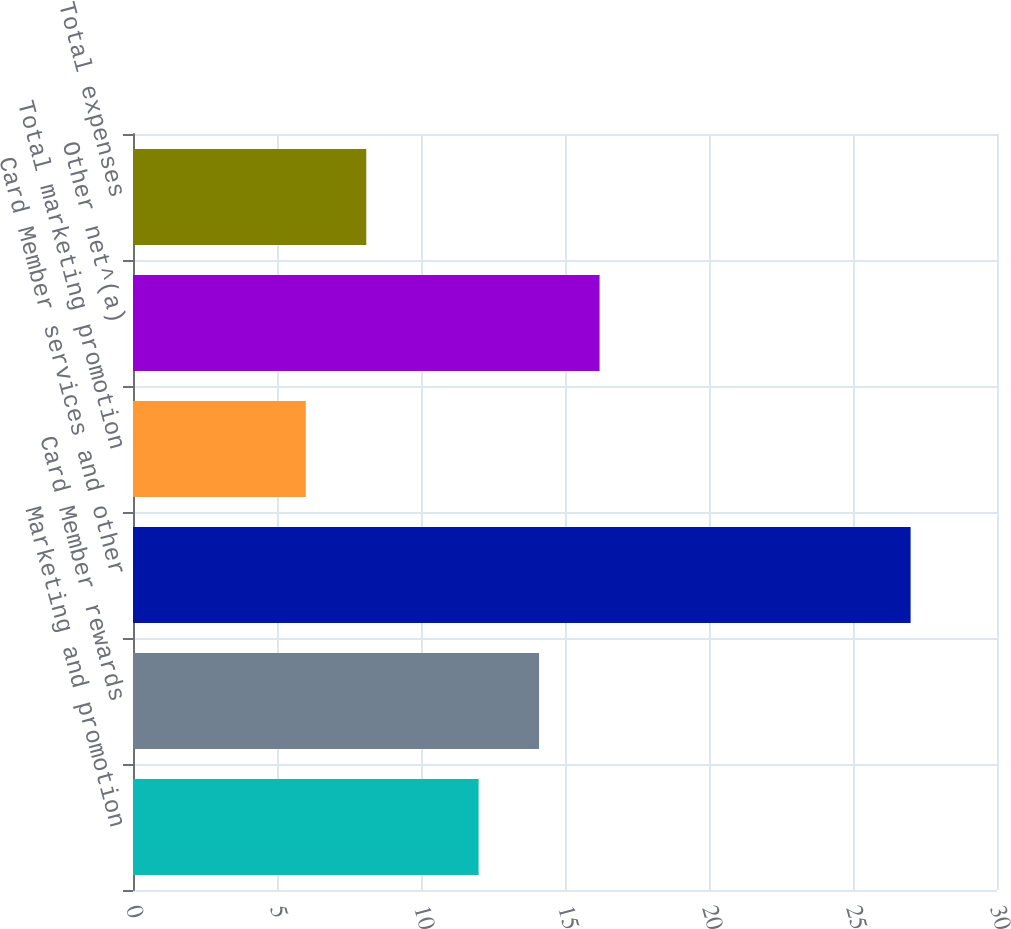<chart> <loc_0><loc_0><loc_500><loc_500><bar_chart><fcel>Marketing and promotion<fcel>Card Member rewards<fcel>Card Member services and other<fcel>Total marketing promotion<fcel>Other net^(a)<fcel>Total expenses<nl><fcel>12<fcel>14.1<fcel>27<fcel>6<fcel>16.2<fcel>8.1<nl></chart> 